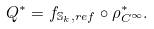Convert formula to latex. <formula><loc_0><loc_0><loc_500><loc_500>Q ^ { * } = f _ { \mathbb { S } _ { k } , r e f } \circ \rho ^ { * } _ { C ^ { \infty } } .</formula> 